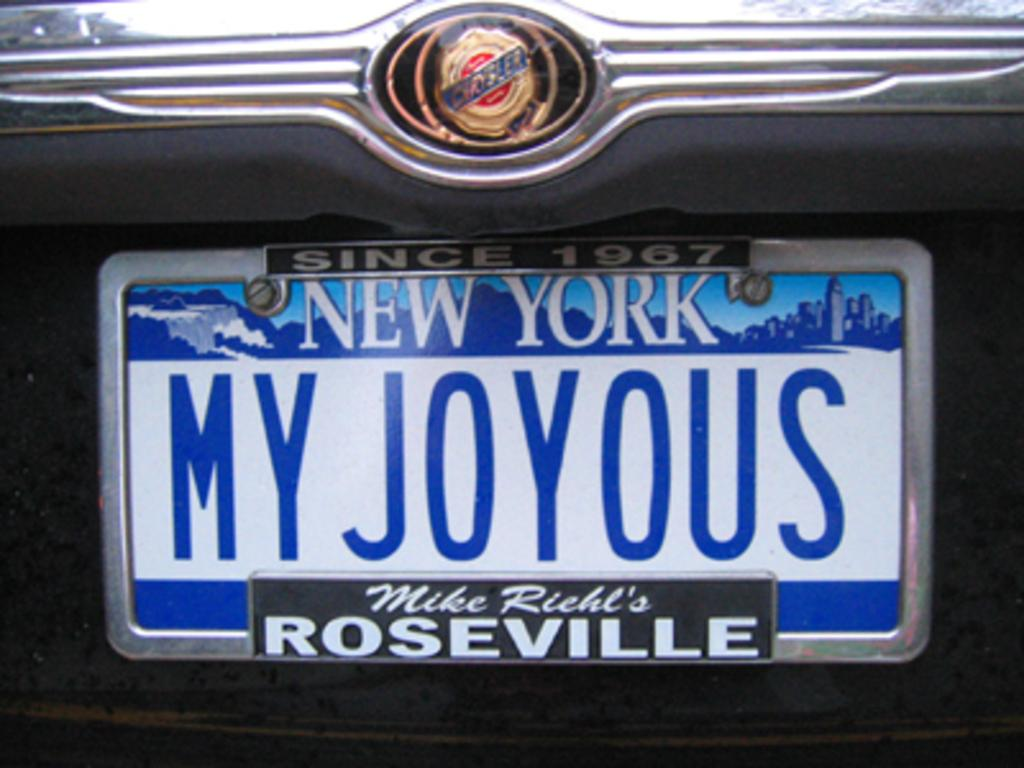Provide a one-sentence caption for the provided image. A license plate for New York says MY JOYOUS. 